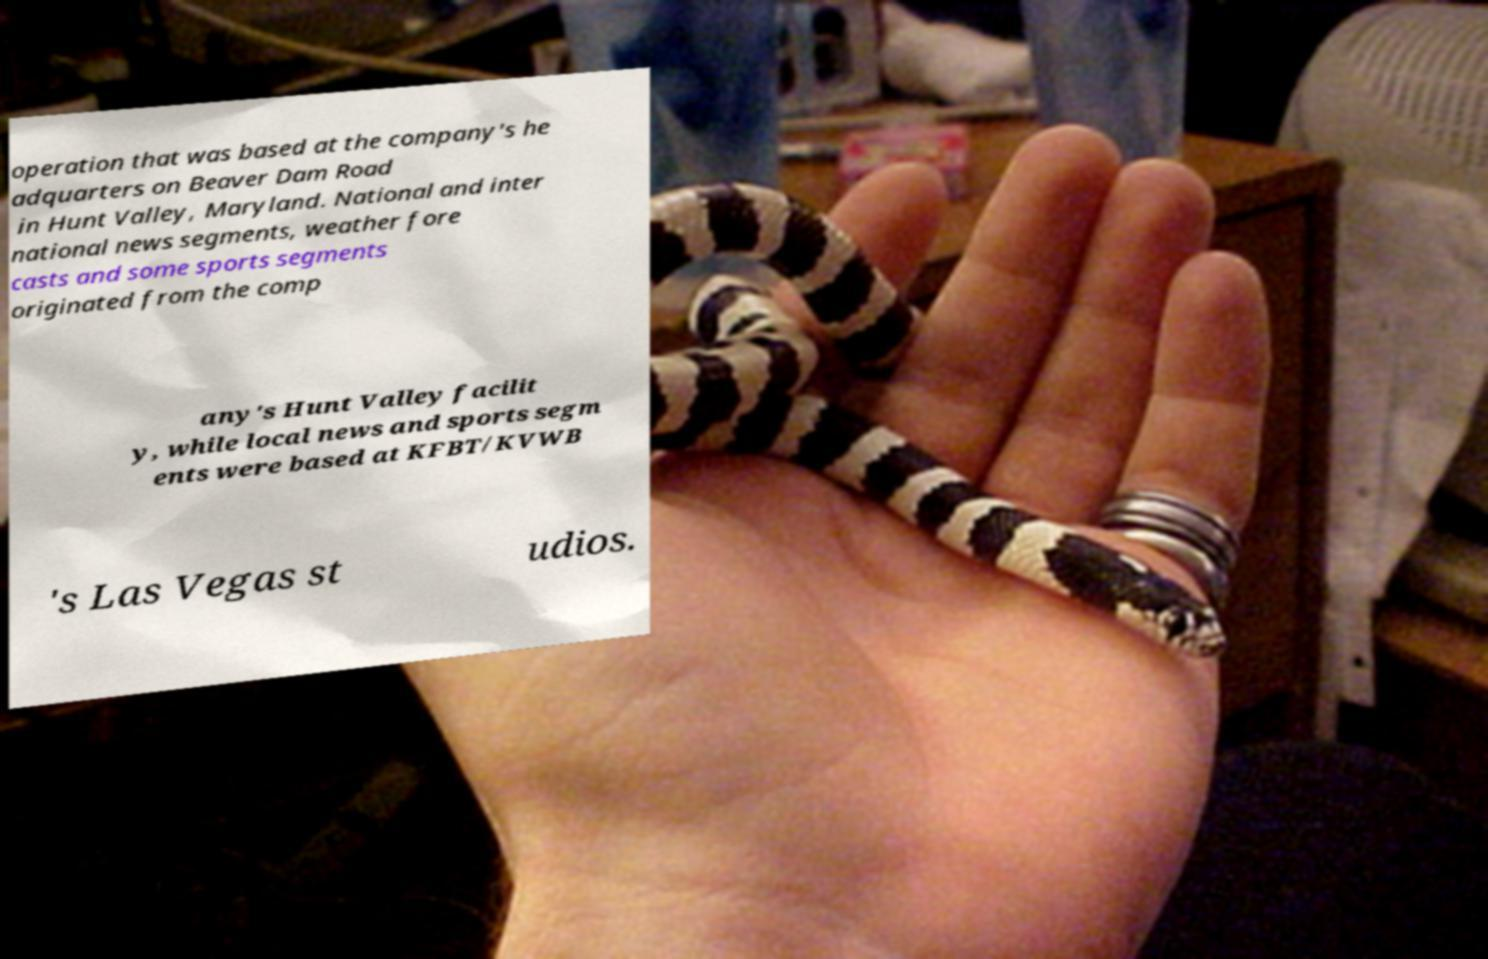Could you extract and type out the text from this image? operation that was based at the company's he adquarters on Beaver Dam Road in Hunt Valley, Maryland. National and inter national news segments, weather fore casts and some sports segments originated from the comp any's Hunt Valley facilit y, while local news and sports segm ents were based at KFBT/KVWB 's Las Vegas st udios. 